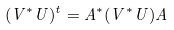Convert formula to latex. <formula><loc_0><loc_0><loc_500><loc_500>( V ^ { * } U ) ^ { t } = A ^ { * } ( V ^ { * } U ) A</formula> 